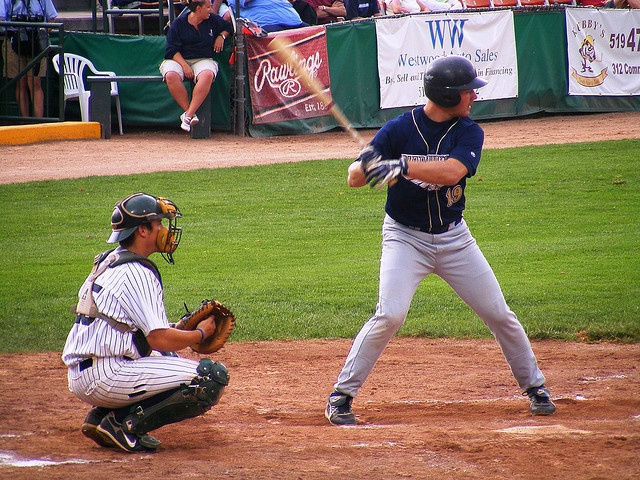Describe the objects in this image and their specific colors. I can see people in darkgray, black, gray, and lavender tones, people in darkgray, lavender, black, gray, and maroon tones, people in darkgray, black, brown, and lavender tones, people in darkgray, black, maroon, navy, and gray tones, and people in darkgray, lightblue, blue, and navy tones in this image. 